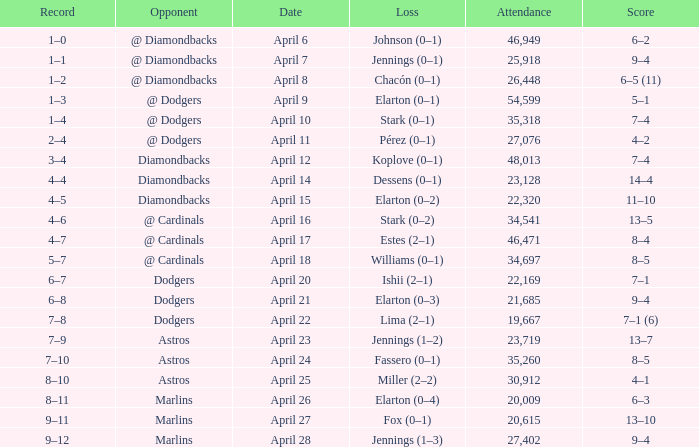Name the score when the opponent was the dodgers on april 21 9–4. Parse the full table. {'header': ['Record', 'Opponent', 'Date', 'Loss', 'Attendance', 'Score'], 'rows': [['1–0', '@ Diamondbacks', 'April 6', 'Johnson (0–1)', '46,949', '6–2'], ['1–1', '@ Diamondbacks', 'April 7', 'Jennings (0–1)', '25,918', '9–4'], ['1–2', '@ Diamondbacks', 'April 8', 'Chacón (0–1)', '26,448', '6–5 (11)'], ['1–3', '@ Dodgers', 'April 9', 'Elarton (0–1)', '54,599', '5–1'], ['1–4', '@ Dodgers', 'April 10', 'Stark (0–1)', '35,318', '7–4'], ['2–4', '@ Dodgers', 'April 11', 'Pérez (0–1)', '27,076', '4–2'], ['3–4', 'Diamondbacks', 'April 12', 'Koplove (0–1)', '48,013', '7–4'], ['4–4', 'Diamondbacks', 'April 14', 'Dessens (0–1)', '23,128', '14–4'], ['4–5', 'Diamondbacks', 'April 15', 'Elarton (0–2)', '22,320', '11–10'], ['4–6', '@ Cardinals', 'April 16', 'Stark (0–2)', '34,541', '13–5'], ['4–7', '@ Cardinals', 'April 17', 'Estes (2–1)', '46,471', '8–4'], ['5–7', '@ Cardinals', 'April 18', 'Williams (0–1)', '34,697', '8–5'], ['6–7', 'Dodgers', 'April 20', 'Ishii (2–1)', '22,169', '7–1'], ['6–8', 'Dodgers', 'April 21', 'Elarton (0–3)', '21,685', '9–4'], ['7–8', 'Dodgers', 'April 22', 'Lima (2–1)', '19,667', '7–1 (6)'], ['7–9', 'Astros', 'April 23', 'Jennings (1–2)', '23,719', '13–7'], ['7–10', 'Astros', 'April 24', 'Fassero (0–1)', '35,260', '8–5'], ['8–10', 'Astros', 'April 25', 'Miller (2–2)', '30,912', '4–1'], ['8–11', 'Marlins', 'April 26', 'Elarton (0–4)', '20,009', '6–3'], ['9–11', 'Marlins', 'April 27', 'Fox (0–1)', '20,615', '13–10'], ['9–12', 'Marlins', 'April 28', 'Jennings (1–3)', '27,402', '9–4']]} 